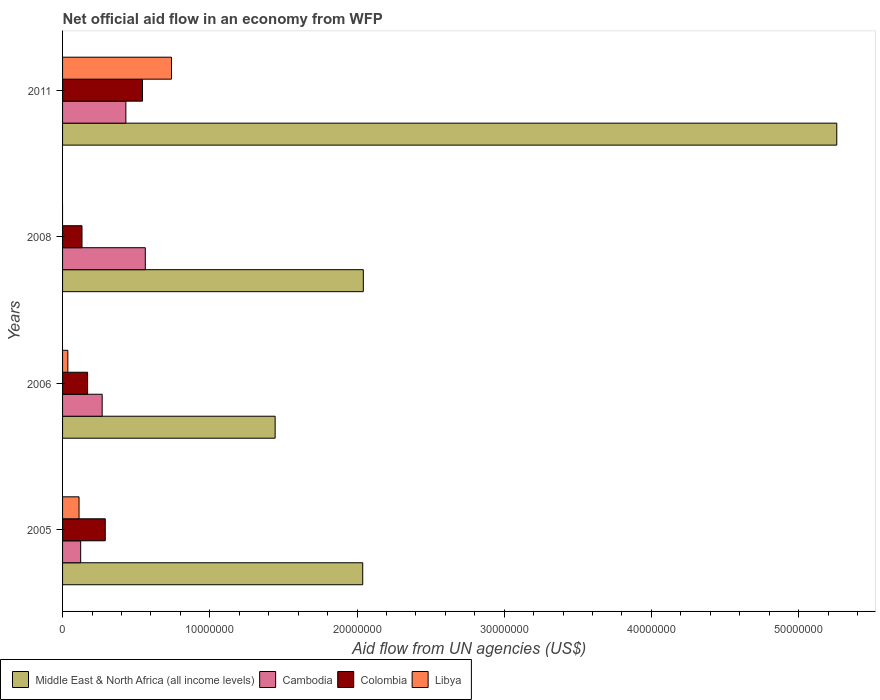How many different coloured bars are there?
Keep it short and to the point. 4. What is the net official aid flow in Middle East & North Africa (all income levels) in 2008?
Give a very brief answer. 2.04e+07. Across all years, what is the maximum net official aid flow in Cambodia?
Ensure brevity in your answer.  5.62e+06. Across all years, what is the minimum net official aid flow in Cambodia?
Make the answer very short. 1.23e+06. What is the total net official aid flow in Colombia in the graph?
Keep it short and to the point. 1.14e+07. What is the difference between the net official aid flow in Libya in 2006 and that in 2011?
Keep it short and to the point. -7.04e+06. What is the difference between the net official aid flow in Cambodia in 2005 and the net official aid flow in Libya in 2011?
Your answer should be very brief. -6.17e+06. What is the average net official aid flow in Cambodia per year?
Your answer should be compact. 3.46e+06. In the year 2005, what is the difference between the net official aid flow in Colombia and net official aid flow in Cambodia?
Make the answer very short. 1.67e+06. What is the ratio of the net official aid flow in Colombia in 2008 to that in 2011?
Provide a succinct answer. 0.24. Is the net official aid flow in Libya in 2005 less than that in 2006?
Make the answer very short. No. What is the difference between the highest and the second highest net official aid flow in Libya?
Your answer should be compact. 6.28e+06. What is the difference between the highest and the lowest net official aid flow in Middle East & North Africa (all income levels)?
Your answer should be compact. 3.82e+07. In how many years, is the net official aid flow in Cambodia greater than the average net official aid flow in Cambodia taken over all years?
Provide a short and direct response. 2. Is it the case that in every year, the sum of the net official aid flow in Cambodia and net official aid flow in Middle East & North Africa (all income levels) is greater than the sum of net official aid flow in Libya and net official aid flow in Colombia?
Give a very brief answer. Yes. Is it the case that in every year, the sum of the net official aid flow in Cambodia and net official aid flow in Middle East & North Africa (all income levels) is greater than the net official aid flow in Colombia?
Offer a terse response. Yes. How many bars are there?
Keep it short and to the point. 15. Are the values on the major ticks of X-axis written in scientific E-notation?
Make the answer very short. No. Does the graph contain any zero values?
Keep it short and to the point. Yes. Does the graph contain grids?
Ensure brevity in your answer.  No. How many legend labels are there?
Make the answer very short. 4. How are the legend labels stacked?
Keep it short and to the point. Horizontal. What is the title of the graph?
Offer a terse response. Net official aid flow in an economy from WFP. Does "Comoros" appear as one of the legend labels in the graph?
Your response must be concise. No. What is the label or title of the X-axis?
Provide a short and direct response. Aid flow from UN agencies (US$). What is the label or title of the Y-axis?
Provide a succinct answer. Years. What is the Aid flow from UN agencies (US$) of Middle East & North Africa (all income levels) in 2005?
Your answer should be compact. 2.04e+07. What is the Aid flow from UN agencies (US$) in Cambodia in 2005?
Offer a terse response. 1.23e+06. What is the Aid flow from UN agencies (US$) in Colombia in 2005?
Your answer should be very brief. 2.90e+06. What is the Aid flow from UN agencies (US$) in Libya in 2005?
Provide a short and direct response. 1.12e+06. What is the Aid flow from UN agencies (US$) of Middle East & North Africa (all income levels) in 2006?
Ensure brevity in your answer.  1.44e+07. What is the Aid flow from UN agencies (US$) in Cambodia in 2006?
Provide a succinct answer. 2.69e+06. What is the Aid flow from UN agencies (US$) in Colombia in 2006?
Make the answer very short. 1.70e+06. What is the Aid flow from UN agencies (US$) of Libya in 2006?
Provide a short and direct response. 3.60e+05. What is the Aid flow from UN agencies (US$) in Middle East & North Africa (all income levels) in 2008?
Provide a succinct answer. 2.04e+07. What is the Aid flow from UN agencies (US$) of Cambodia in 2008?
Ensure brevity in your answer.  5.62e+06. What is the Aid flow from UN agencies (US$) of Colombia in 2008?
Your answer should be very brief. 1.32e+06. What is the Aid flow from UN agencies (US$) of Libya in 2008?
Give a very brief answer. 0. What is the Aid flow from UN agencies (US$) of Middle East & North Africa (all income levels) in 2011?
Ensure brevity in your answer.  5.26e+07. What is the Aid flow from UN agencies (US$) of Cambodia in 2011?
Your answer should be compact. 4.30e+06. What is the Aid flow from UN agencies (US$) in Colombia in 2011?
Provide a short and direct response. 5.43e+06. What is the Aid flow from UN agencies (US$) in Libya in 2011?
Provide a succinct answer. 7.40e+06. Across all years, what is the maximum Aid flow from UN agencies (US$) in Middle East & North Africa (all income levels)?
Offer a very short reply. 5.26e+07. Across all years, what is the maximum Aid flow from UN agencies (US$) in Cambodia?
Offer a terse response. 5.62e+06. Across all years, what is the maximum Aid flow from UN agencies (US$) in Colombia?
Ensure brevity in your answer.  5.43e+06. Across all years, what is the maximum Aid flow from UN agencies (US$) of Libya?
Make the answer very short. 7.40e+06. Across all years, what is the minimum Aid flow from UN agencies (US$) in Middle East & North Africa (all income levels)?
Offer a very short reply. 1.44e+07. Across all years, what is the minimum Aid flow from UN agencies (US$) in Cambodia?
Give a very brief answer. 1.23e+06. Across all years, what is the minimum Aid flow from UN agencies (US$) in Colombia?
Your answer should be very brief. 1.32e+06. Across all years, what is the minimum Aid flow from UN agencies (US$) in Libya?
Make the answer very short. 0. What is the total Aid flow from UN agencies (US$) of Middle East & North Africa (all income levels) in the graph?
Offer a very short reply. 1.08e+08. What is the total Aid flow from UN agencies (US$) of Cambodia in the graph?
Your answer should be compact. 1.38e+07. What is the total Aid flow from UN agencies (US$) of Colombia in the graph?
Keep it short and to the point. 1.14e+07. What is the total Aid flow from UN agencies (US$) of Libya in the graph?
Your answer should be very brief. 8.88e+06. What is the difference between the Aid flow from UN agencies (US$) in Middle East & North Africa (all income levels) in 2005 and that in 2006?
Keep it short and to the point. 5.95e+06. What is the difference between the Aid flow from UN agencies (US$) of Cambodia in 2005 and that in 2006?
Your answer should be compact. -1.46e+06. What is the difference between the Aid flow from UN agencies (US$) in Colombia in 2005 and that in 2006?
Keep it short and to the point. 1.20e+06. What is the difference between the Aid flow from UN agencies (US$) of Libya in 2005 and that in 2006?
Give a very brief answer. 7.60e+05. What is the difference between the Aid flow from UN agencies (US$) in Middle East & North Africa (all income levels) in 2005 and that in 2008?
Offer a very short reply. -4.00e+04. What is the difference between the Aid flow from UN agencies (US$) of Cambodia in 2005 and that in 2008?
Your response must be concise. -4.39e+06. What is the difference between the Aid flow from UN agencies (US$) in Colombia in 2005 and that in 2008?
Ensure brevity in your answer.  1.58e+06. What is the difference between the Aid flow from UN agencies (US$) in Middle East & North Africa (all income levels) in 2005 and that in 2011?
Keep it short and to the point. -3.22e+07. What is the difference between the Aid flow from UN agencies (US$) in Cambodia in 2005 and that in 2011?
Keep it short and to the point. -3.07e+06. What is the difference between the Aid flow from UN agencies (US$) of Colombia in 2005 and that in 2011?
Offer a very short reply. -2.53e+06. What is the difference between the Aid flow from UN agencies (US$) in Libya in 2005 and that in 2011?
Offer a terse response. -6.28e+06. What is the difference between the Aid flow from UN agencies (US$) of Middle East & North Africa (all income levels) in 2006 and that in 2008?
Give a very brief answer. -5.99e+06. What is the difference between the Aid flow from UN agencies (US$) of Cambodia in 2006 and that in 2008?
Provide a succinct answer. -2.93e+06. What is the difference between the Aid flow from UN agencies (US$) of Colombia in 2006 and that in 2008?
Provide a short and direct response. 3.80e+05. What is the difference between the Aid flow from UN agencies (US$) of Middle East & North Africa (all income levels) in 2006 and that in 2011?
Offer a terse response. -3.82e+07. What is the difference between the Aid flow from UN agencies (US$) of Cambodia in 2006 and that in 2011?
Your answer should be compact. -1.61e+06. What is the difference between the Aid flow from UN agencies (US$) in Colombia in 2006 and that in 2011?
Make the answer very short. -3.73e+06. What is the difference between the Aid flow from UN agencies (US$) in Libya in 2006 and that in 2011?
Provide a succinct answer. -7.04e+06. What is the difference between the Aid flow from UN agencies (US$) in Middle East & North Africa (all income levels) in 2008 and that in 2011?
Give a very brief answer. -3.22e+07. What is the difference between the Aid flow from UN agencies (US$) in Cambodia in 2008 and that in 2011?
Provide a succinct answer. 1.32e+06. What is the difference between the Aid flow from UN agencies (US$) in Colombia in 2008 and that in 2011?
Provide a succinct answer. -4.11e+06. What is the difference between the Aid flow from UN agencies (US$) of Middle East & North Africa (all income levels) in 2005 and the Aid flow from UN agencies (US$) of Cambodia in 2006?
Keep it short and to the point. 1.77e+07. What is the difference between the Aid flow from UN agencies (US$) of Middle East & North Africa (all income levels) in 2005 and the Aid flow from UN agencies (US$) of Colombia in 2006?
Provide a succinct answer. 1.87e+07. What is the difference between the Aid flow from UN agencies (US$) of Middle East & North Africa (all income levels) in 2005 and the Aid flow from UN agencies (US$) of Libya in 2006?
Offer a very short reply. 2.00e+07. What is the difference between the Aid flow from UN agencies (US$) in Cambodia in 2005 and the Aid flow from UN agencies (US$) in Colombia in 2006?
Your response must be concise. -4.70e+05. What is the difference between the Aid flow from UN agencies (US$) in Cambodia in 2005 and the Aid flow from UN agencies (US$) in Libya in 2006?
Offer a very short reply. 8.70e+05. What is the difference between the Aid flow from UN agencies (US$) of Colombia in 2005 and the Aid flow from UN agencies (US$) of Libya in 2006?
Your answer should be very brief. 2.54e+06. What is the difference between the Aid flow from UN agencies (US$) in Middle East & North Africa (all income levels) in 2005 and the Aid flow from UN agencies (US$) in Cambodia in 2008?
Your response must be concise. 1.48e+07. What is the difference between the Aid flow from UN agencies (US$) in Middle East & North Africa (all income levels) in 2005 and the Aid flow from UN agencies (US$) in Colombia in 2008?
Your answer should be compact. 1.91e+07. What is the difference between the Aid flow from UN agencies (US$) of Cambodia in 2005 and the Aid flow from UN agencies (US$) of Colombia in 2008?
Offer a terse response. -9.00e+04. What is the difference between the Aid flow from UN agencies (US$) of Middle East & North Africa (all income levels) in 2005 and the Aid flow from UN agencies (US$) of Cambodia in 2011?
Your answer should be compact. 1.61e+07. What is the difference between the Aid flow from UN agencies (US$) of Middle East & North Africa (all income levels) in 2005 and the Aid flow from UN agencies (US$) of Colombia in 2011?
Provide a succinct answer. 1.50e+07. What is the difference between the Aid flow from UN agencies (US$) in Middle East & North Africa (all income levels) in 2005 and the Aid flow from UN agencies (US$) in Libya in 2011?
Keep it short and to the point. 1.30e+07. What is the difference between the Aid flow from UN agencies (US$) in Cambodia in 2005 and the Aid flow from UN agencies (US$) in Colombia in 2011?
Your response must be concise. -4.20e+06. What is the difference between the Aid flow from UN agencies (US$) in Cambodia in 2005 and the Aid flow from UN agencies (US$) in Libya in 2011?
Make the answer very short. -6.17e+06. What is the difference between the Aid flow from UN agencies (US$) in Colombia in 2005 and the Aid flow from UN agencies (US$) in Libya in 2011?
Make the answer very short. -4.50e+06. What is the difference between the Aid flow from UN agencies (US$) in Middle East & North Africa (all income levels) in 2006 and the Aid flow from UN agencies (US$) in Cambodia in 2008?
Your response must be concise. 8.82e+06. What is the difference between the Aid flow from UN agencies (US$) of Middle East & North Africa (all income levels) in 2006 and the Aid flow from UN agencies (US$) of Colombia in 2008?
Ensure brevity in your answer.  1.31e+07. What is the difference between the Aid flow from UN agencies (US$) in Cambodia in 2006 and the Aid flow from UN agencies (US$) in Colombia in 2008?
Ensure brevity in your answer.  1.37e+06. What is the difference between the Aid flow from UN agencies (US$) in Middle East & North Africa (all income levels) in 2006 and the Aid flow from UN agencies (US$) in Cambodia in 2011?
Keep it short and to the point. 1.01e+07. What is the difference between the Aid flow from UN agencies (US$) of Middle East & North Africa (all income levels) in 2006 and the Aid flow from UN agencies (US$) of Colombia in 2011?
Provide a short and direct response. 9.01e+06. What is the difference between the Aid flow from UN agencies (US$) of Middle East & North Africa (all income levels) in 2006 and the Aid flow from UN agencies (US$) of Libya in 2011?
Your answer should be very brief. 7.04e+06. What is the difference between the Aid flow from UN agencies (US$) of Cambodia in 2006 and the Aid flow from UN agencies (US$) of Colombia in 2011?
Ensure brevity in your answer.  -2.74e+06. What is the difference between the Aid flow from UN agencies (US$) in Cambodia in 2006 and the Aid flow from UN agencies (US$) in Libya in 2011?
Offer a terse response. -4.71e+06. What is the difference between the Aid flow from UN agencies (US$) of Colombia in 2006 and the Aid flow from UN agencies (US$) of Libya in 2011?
Your answer should be very brief. -5.70e+06. What is the difference between the Aid flow from UN agencies (US$) of Middle East & North Africa (all income levels) in 2008 and the Aid flow from UN agencies (US$) of Cambodia in 2011?
Make the answer very short. 1.61e+07. What is the difference between the Aid flow from UN agencies (US$) of Middle East & North Africa (all income levels) in 2008 and the Aid flow from UN agencies (US$) of Colombia in 2011?
Your response must be concise. 1.50e+07. What is the difference between the Aid flow from UN agencies (US$) in Middle East & North Africa (all income levels) in 2008 and the Aid flow from UN agencies (US$) in Libya in 2011?
Your response must be concise. 1.30e+07. What is the difference between the Aid flow from UN agencies (US$) of Cambodia in 2008 and the Aid flow from UN agencies (US$) of Libya in 2011?
Offer a terse response. -1.78e+06. What is the difference between the Aid flow from UN agencies (US$) of Colombia in 2008 and the Aid flow from UN agencies (US$) of Libya in 2011?
Give a very brief answer. -6.08e+06. What is the average Aid flow from UN agencies (US$) in Middle East & North Africa (all income levels) per year?
Keep it short and to the point. 2.70e+07. What is the average Aid flow from UN agencies (US$) in Cambodia per year?
Provide a short and direct response. 3.46e+06. What is the average Aid flow from UN agencies (US$) in Colombia per year?
Provide a short and direct response. 2.84e+06. What is the average Aid flow from UN agencies (US$) in Libya per year?
Keep it short and to the point. 2.22e+06. In the year 2005, what is the difference between the Aid flow from UN agencies (US$) of Middle East & North Africa (all income levels) and Aid flow from UN agencies (US$) of Cambodia?
Your response must be concise. 1.92e+07. In the year 2005, what is the difference between the Aid flow from UN agencies (US$) in Middle East & North Africa (all income levels) and Aid flow from UN agencies (US$) in Colombia?
Your answer should be very brief. 1.75e+07. In the year 2005, what is the difference between the Aid flow from UN agencies (US$) of Middle East & North Africa (all income levels) and Aid flow from UN agencies (US$) of Libya?
Give a very brief answer. 1.93e+07. In the year 2005, what is the difference between the Aid flow from UN agencies (US$) in Cambodia and Aid flow from UN agencies (US$) in Colombia?
Your response must be concise. -1.67e+06. In the year 2005, what is the difference between the Aid flow from UN agencies (US$) in Cambodia and Aid flow from UN agencies (US$) in Libya?
Provide a short and direct response. 1.10e+05. In the year 2005, what is the difference between the Aid flow from UN agencies (US$) of Colombia and Aid flow from UN agencies (US$) of Libya?
Provide a succinct answer. 1.78e+06. In the year 2006, what is the difference between the Aid flow from UN agencies (US$) of Middle East & North Africa (all income levels) and Aid flow from UN agencies (US$) of Cambodia?
Keep it short and to the point. 1.18e+07. In the year 2006, what is the difference between the Aid flow from UN agencies (US$) of Middle East & North Africa (all income levels) and Aid flow from UN agencies (US$) of Colombia?
Offer a terse response. 1.27e+07. In the year 2006, what is the difference between the Aid flow from UN agencies (US$) of Middle East & North Africa (all income levels) and Aid flow from UN agencies (US$) of Libya?
Give a very brief answer. 1.41e+07. In the year 2006, what is the difference between the Aid flow from UN agencies (US$) in Cambodia and Aid flow from UN agencies (US$) in Colombia?
Your response must be concise. 9.90e+05. In the year 2006, what is the difference between the Aid flow from UN agencies (US$) of Cambodia and Aid flow from UN agencies (US$) of Libya?
Give a very brief answer. 2.33e+06. In the year 2006, what is the difference between the Aid flow from UN agencies (US$) of Colombia and Aid flow from UN agencies (US$) of Libya?
Offer a terse response. 1.34e+06. In the year 2008, what is the difference between the Aid flow from UN agencies (US$) in Middle East & North Africa (all income levels) and Aid flow from UN agencies (US$) in Cambodia?
Provide a short and direct response. 1.48e+07. In the year 2008, what is the difference between the Aid flow from UN agencies (US$) of Middle East & North Africa (all income levels) and Aid flow from UN agencies (US$) of Colombia?
Keep it short and to the point. 1.91e+07. In the year 2008, what is the difference between the Aid flow from UN agencies (US$) of Cambodia and Aid flow from UN agencies (US$) of Colombia?
Make the answer very short. 4.30e+06. In the year 2011, what is the difference between the Aid flow from UN agencies (US$) in Middle East & North Africa (all income levels) and Aid flow from UN agencies (US$) in Cambodia?
Your answer should be very brief. 4.83e+07. In the year 2011, what is the difference between the Aid flow from UN agencies (US$) in Middle East & North Africa (all income levels) and Aid flow from UN agencies (US$) in Colombia?
Ensure brevity in your answer.  4.72e+07. In the year 2011, what is the difference between the Aid flow from UN agencies (US$) of Middle East & North Africa (all income levels) and Aid flow from UN agencies (US$) of Libya?
Your answer should be compact. 4.52e+07. In the year 2011, what is the difference between the Aid flow from UN agencies (US$) of Cambodia and Aid flow from UN agencies (US$) of Colombia?
Provide a short and direct response. -1.13e+06. In the year 2011, what is the difference between the Aid flow from UN agencies (US$) in Cambodia and Aid flow from UN agencies (US$) in Libya?
Keep it short and to the point. -3.10e+06. In the year 2011, what is the difference between the Aid flow from UN agencies (US$) in Colombia and Aid flow from UN agencies (US$) in Libya?
Provide a short and direct response. -1.97e+06. What is the ratio of the Aid flow from UN agencies (US$) of Middle East & North Africa (all income levels) in 2005 to that in 2006?
Offer a very short reply. 1.41. What is the ratio of the Aid flow from UN agencies (US$) in Cambodia in 2005 to that in 2006?
Provide a short and direct response. 0.46. What is the ratio of the Aid flow from UN agencies (US$) of Colombia in 2005 to that in 2006?
Keep it short and to the point. 1.71. What is the ratio of the Aid flow from UN agencies (US$) in Libya in 2005 to that in 2006?
Your answer should be very brief. 3.11. What is the ratio of the Aid flow from UN agencies (US$) in Cambodia in 2005 to that in 2008?
Provide a succinct answer. 0.22. What is the ratio of the Aid flow from UN agencies (US$) in Colombia in 2005 to that in 2008?
Make the answer very short. 2.2. What is the ratio of the Aid flow from UN agencies (US$) of Middle East & North Africa (all income levels) in 2005 to that in 2011?
Your response must be concise. 0.39. What is the ratio of the Aid flow from UN agencies (US$) in Cambodia in 2005 to that in 2011?
Make the answer very short. 0.29. What is the ratio of the Aid flow from UN agencies (US$) in Colombia in 2005 to that in 2011?
Keep it short and to the point. 0.53. What is the ratio of the Aid flow from UN agencies (US$) in Libya in 2005 to that in 2011?
Ensure brevity in your answer.  0.15. What is the ratio of the Aid flow from UN agencies (US$) in Middle East & North Africa (all income levels) in 2006 to that in 2008?
Provide a short and direct response. 0.71. What is the ratio of the Aid flow from UN agencies (US$) of Cambodia in 2006 to that in 2008?
Your response must be concise. 0.48. What is the ratio of the Aid flow from UN agencies (US$) of Colombia in 2006 to that in 2008?
Give a very brief answer. 1.29. What is the ratio of the Aid flow from UN agencies (US$) in Middle East & North Africa (all income levels) in 2006 to that in 2011?
Ensure brevity in your answer.  0.27. What is the ratio of the Aid flow from UN agencies (US$) of Cambodia in 2006 to that in 2011?
Keep it short and to the point. 0.63. What is the ratio of the Aid flow from UN agencies (US$) of Colombia in 2006 to that in 2011?
Provide a short and direct response. 0.31. What is the ratio of the Aid flow from UN agencies (US$) of Libya in 2006 to that in 2011?
Ensure brevity in your answer.  0.05. What is the ratio of the Aid flow from UN agencies (US$) of Middle East & North Africa (all income levels) in 2008 to that in 2011?
Provide a succinct answer. 0.39. What is the ratio of the Aid flow from UN agencies (US$) of Cambodia in 2008 to that in 2011?
Offer a terse response. 1.31. What is the ratio of the Aid flow from UN agencies (US$) in Colombia in 2008 to that in 2011?
Make the answer very short. 0.24. What is the difference between the highest and the second highest Aid flow from UN agencies (US$) in Middle East & North Africa (all income levels)?
Ensure brevity in your answer.  3.22e+07. What is the difference between the highest and the second highest Aid flow from UN agencies (US$) in Cambodia?
Make the answer very short. 1.32e+06. What is the difference between the highest and the second highest Aid flow from UN agencies (US$) of Colombia?
Make the answer very short. 2.53e+06. What is the difference between the highest and the second highest Aid flow from UN agencies (US$) in Libya?
Keep it short and to the point. 6.28e+06. What is the difference between the highest and the lowest Aid flow from UN agencies (US$) of Middle East & North Africa (all income levels)?
Provide a short and direct response. 3.82e+07. What is the difference between the highest and the lowest Aid flow from UN agencies (US$) in Cambodia?
Offer a very short reply. 4.39e+06. What is the difference between the highest and the lowest Aid flow from UN agencies (US$) in Colombia?
Make the answer very short. 4.11e+06. What is the difference between the highest and the lowest Aid flow from UN agencies (US$) of Libya?
Keep it short and to the point. 7.40e+06. 